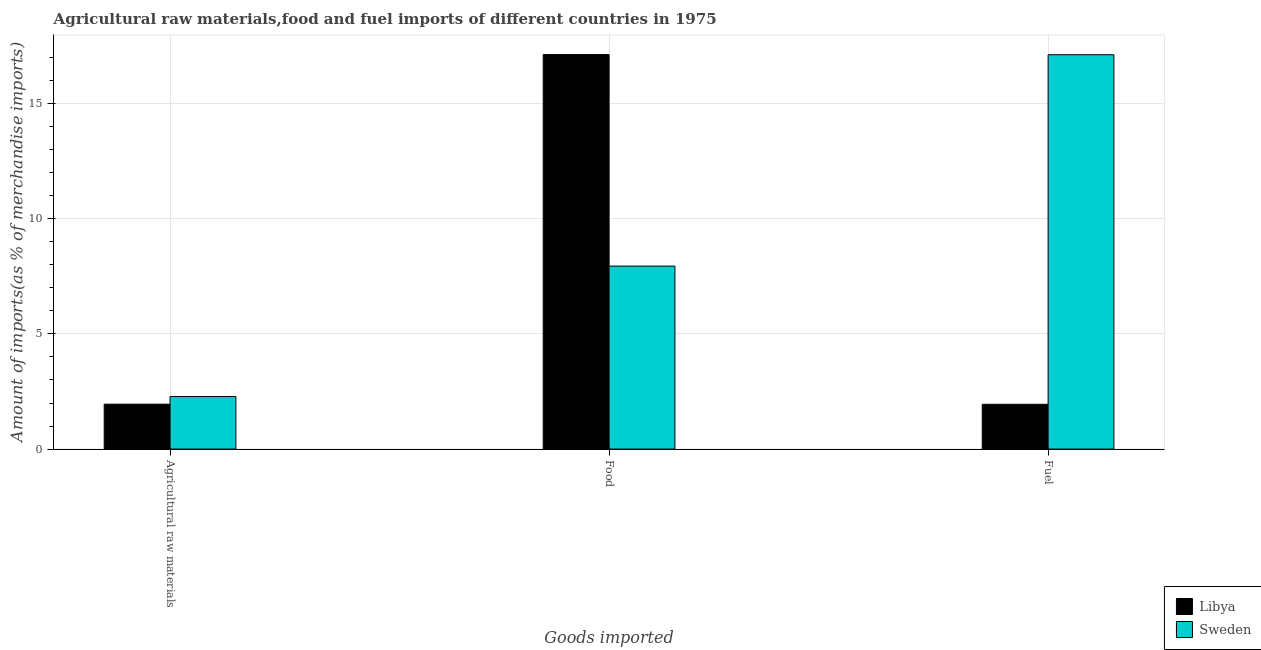Are the number of bars per tick equal to the number of legend labels?
Ensure brevity in your answer.  Yes. Are the number of bars on each tick of the X-axis equal?
Offer a very short reply. Yes. How many bars are there on the 1st tick from the right?
Offer a terse response. 2. What is the label of the 1st group of bars from the left?
Make the answer very short. Agricultural raw materials. What is the percentage of food imports in Libya?
Your answer should be compact. 17.13. Across all countries, what is the maximum percentage of food imports?
Provide a short and direct response. 17.13. Across all countries, what is the minimum percentage of raw materials imports?
Provide a succinct answer. 1.95. In which country was the percentage of food imports maximum?
Offer a very short reply. Libya. What is the total percentage of food imports in the graph?
Your answer should be very brief. 25.08. What is the difference between the percentage of fuel imports in Sweden and that in Libya?
Give a very brief answer. 15.18. What is the difference between the percentage of food imports in Libya and the percentage of raw materials imports in Sweden?
Your answer should be compact. 14.85. What is the average percentage of fuel imports per country?
Offer a terse response. 9.53. What is the difference between the percentage of raw materials imports and percentage of fuel imports in Libya?
Your response must be concise. 0. What is the ratio of the percentage of fuel imports in Sweden to that in Libya?
Give a very brief answer. 8.81. Is the percentage of raw materials imports in Libya less than that in Sweden?
Give a very brief answer. Yes. What is the difference between the highest and the second highest percentage of food imports?
Keep it short and to the point. 9.18. What is the difference between the highest and the lowest percentage of food imports?
Your response must be concise. 9.18. In how many countries, is the percentage of fuel imports greater than the average percentage of fuel imports taken over all countries?
Ensure brevity in your answer.  1. Is the sum of the percentage of food imports in Sweden and Libya greater than the maximum percentage of fuel imports across all countries?
Offer a terse response. Yes. What does the 1st bar from the left in Fuel represents?
Offer a terse response. Libya. What does the 1st bar from the right in Fuel represents?
Offer a very short reply. Sweden. Is it the case that in every country, the sum of the percentage of raw materials imports and percentage of food imports is greater than the percentage of fuel imports?
Provide a succinct answer. No. How many countries are there in the graph?
Provide a short and direct response. 2. Are the values on the major ticks of Y-axis written in scientific E-notation?
Keep it short and to the point. No. Does the graph contain grids?
Give a very brief answer. Yes. What is the title of the graph?
Offer a very short reply. Agricultural raw materials,food and fuel imports of different countries in 1975. What is the label or title of the X-axis?
Keep it short and to the point. Goods imported. What is the label or title of the Y-axis?
Your answer should be very brief. Amount of imports(as % of merchandise imports). What is the Amount of imports(as % of merchandise imports) of Libya in Agricultural raw materials?
Ensure brevity in your answer.  1.95. What is the Amount of imports(as % of merchandise imports) of Sweden in Agricultural raw materials?
Make the answer very short. 2.28. What is the Amount of imports(as % of merchandise imports) in Libya in Food?
Provide a short and direct response. 17.13. What is the Amount of imports(as % of merchandise imports) of Sweden in Food?
Offer a terse response. 7.95. What is the Amount of imports(as % of merchandise imports) in Libya in Fuel?
Provide a succinct answer. 1.94. What is the Amount of imports(as % of merchandise imports) in Sweden in Fuel?
Provide a short and direct response. 17.12. Across all Goods imported, what is the maximum Amount of imports(as % of merchandise imports) in Libya?
Your answer should be very brief. 17.13. Across all Goods imported, what is the maximum Amount of imports(as % of merchandise imports) in Sweden?
Keep it short and to the point. 17.12. Across all Goods imported, what is the minimum Amount of imports(as % of merchandise imports) in Libya?
Provide a short and direct response. 1.94. Across all Goods imported, what is the minimum Amount of imports(as % of merchandise imports) of Sweden?
Provide a short and direct response. 2.28. What is the total Amount of imports(as % of merchandise imports) of Libya in the graph?
Offer a very short reply. 21.02. What is the total Amount of imports(as % of merchandise imports) of Sweden in the graph?
Ensure brevity in your answer.  27.35. What is the difference between the Amount of imports(as % of merchandise imports) of Libya in Agricultural raw materials and that in Food?
Your answer should be very brief. -15.18. What is the difference between the Amount of imports(as % of merchandise imports) of Sweden in Agricultural raw materials and that in Food?
Keep it short and to the point. -5.66. What is the difference between the Amount of imports(as % of merchandise imports) of Libya in Agricultural raw materials and that in Fuel?
Provide a short and direct response. 0. What is the difference between the Amount of imports(as % of merchandise imports) of Sweden in Agricultural raw materials and that in Fuel?
Provide a short and direct response. -14.84. What is the difference between the Amount of imports(as % of merchandise imports) of Libya in Food and that in Fuel?
Provide a succinct answer. 15.19. What is the difference between the Amount of imports(as % of merchandise imports) of Sweden in Food and that in Fuel?
Your answer should be compact. -9.18. What is the difference between the Amount of imports(as % of merchandise imports) of Libya in Agricultural raw materials and the Amount of imports(as % of merchandise imports) of Sweden in Food?
Give a very brief answer. -6. What is the difference between the Amount of imports(as % of merchandise imports) in Libya in Agricultural raw materials and the Amount of imports(as % of merchandise imports) in Sweden in Fuel?
Give a very brief answer. -15.18. What is the difference between the Amount of imports(as % of merchandise imports) in Libya in Food and the Amount of imports(as % of merchandise imports) in Sweden in Fuel?
Offer a terse response. 0.01. What is the average Amount of imports(as % of merchandise imports) of Libya per Goods imported?
Keep it short and to the point. 7.01. What is the average Amount of imports(as % of merchandise imports) in Sweden per Goods imported?
Provide a succinct answer. 9.12. What is the difference between the Amount of imports(as % of merchandise imports) in Libya and Amount of imports(as % of merchandise imports) in Sweden in Agricultural raw materials?
Your answer should be compact. -0.33. What is the difference between the Amount of imports(as % of merchandise imports) of Libya and Amount of imports(as % of merchandise imports) of Sweden in Food?
Give a very brief answer. 9.18. What is the difference between the Amount of imports(as % of merchandise imports) in Libya and Amount of imports(as % of merchandise imports) in Sweden in Fuel?
Your response must be concise. -15.18. What is the ratio of the Amount of imports(as % of merchandise imports) of Libya in Agricultural raw materials to that in Food?
Offer a terse response. 0.11. What is the ratio of the Amount of imports(as % of merchandise imports) in Sweden in Agricultural raw materials to that in Food?
Ensure brevity in your answer.  0.29. What is the ratio of the Amount of imports(as % of merchandise imports) of Sweden in Agricultural raw materials to that in Fuel?
Ensure brevity in your answer.  0.13. What is the ratio of the Amount of imports(as % of merchandise imports) in Libya in Food to that in Fuel?
Offer a very short reply. 8.81. What is the ratio of the Amount of imports(as % of merchandise imports) of Sweden in Food to that in Fuel?
Provide a succinct answer. 0.46. What is the difference between the highest and the second highest Amount of imports(as % of merchandise imports) in Libya?
Give a very brief answer. 15.18. What is the difference between the highest and the second highest Amount of imports(as % of merchandise imports) of Sweden?
Your response must be concise. 9.18. What is the difference between the highest and the lowest Amount of imports(as % of merchandise imports) in Libya?
Provide a short and direct response. 15.19. What is the difference between the highest and the lowest Amount of imports(as % of merchandise imports) of Sweden?
Give a very brief answer. 14.84. 